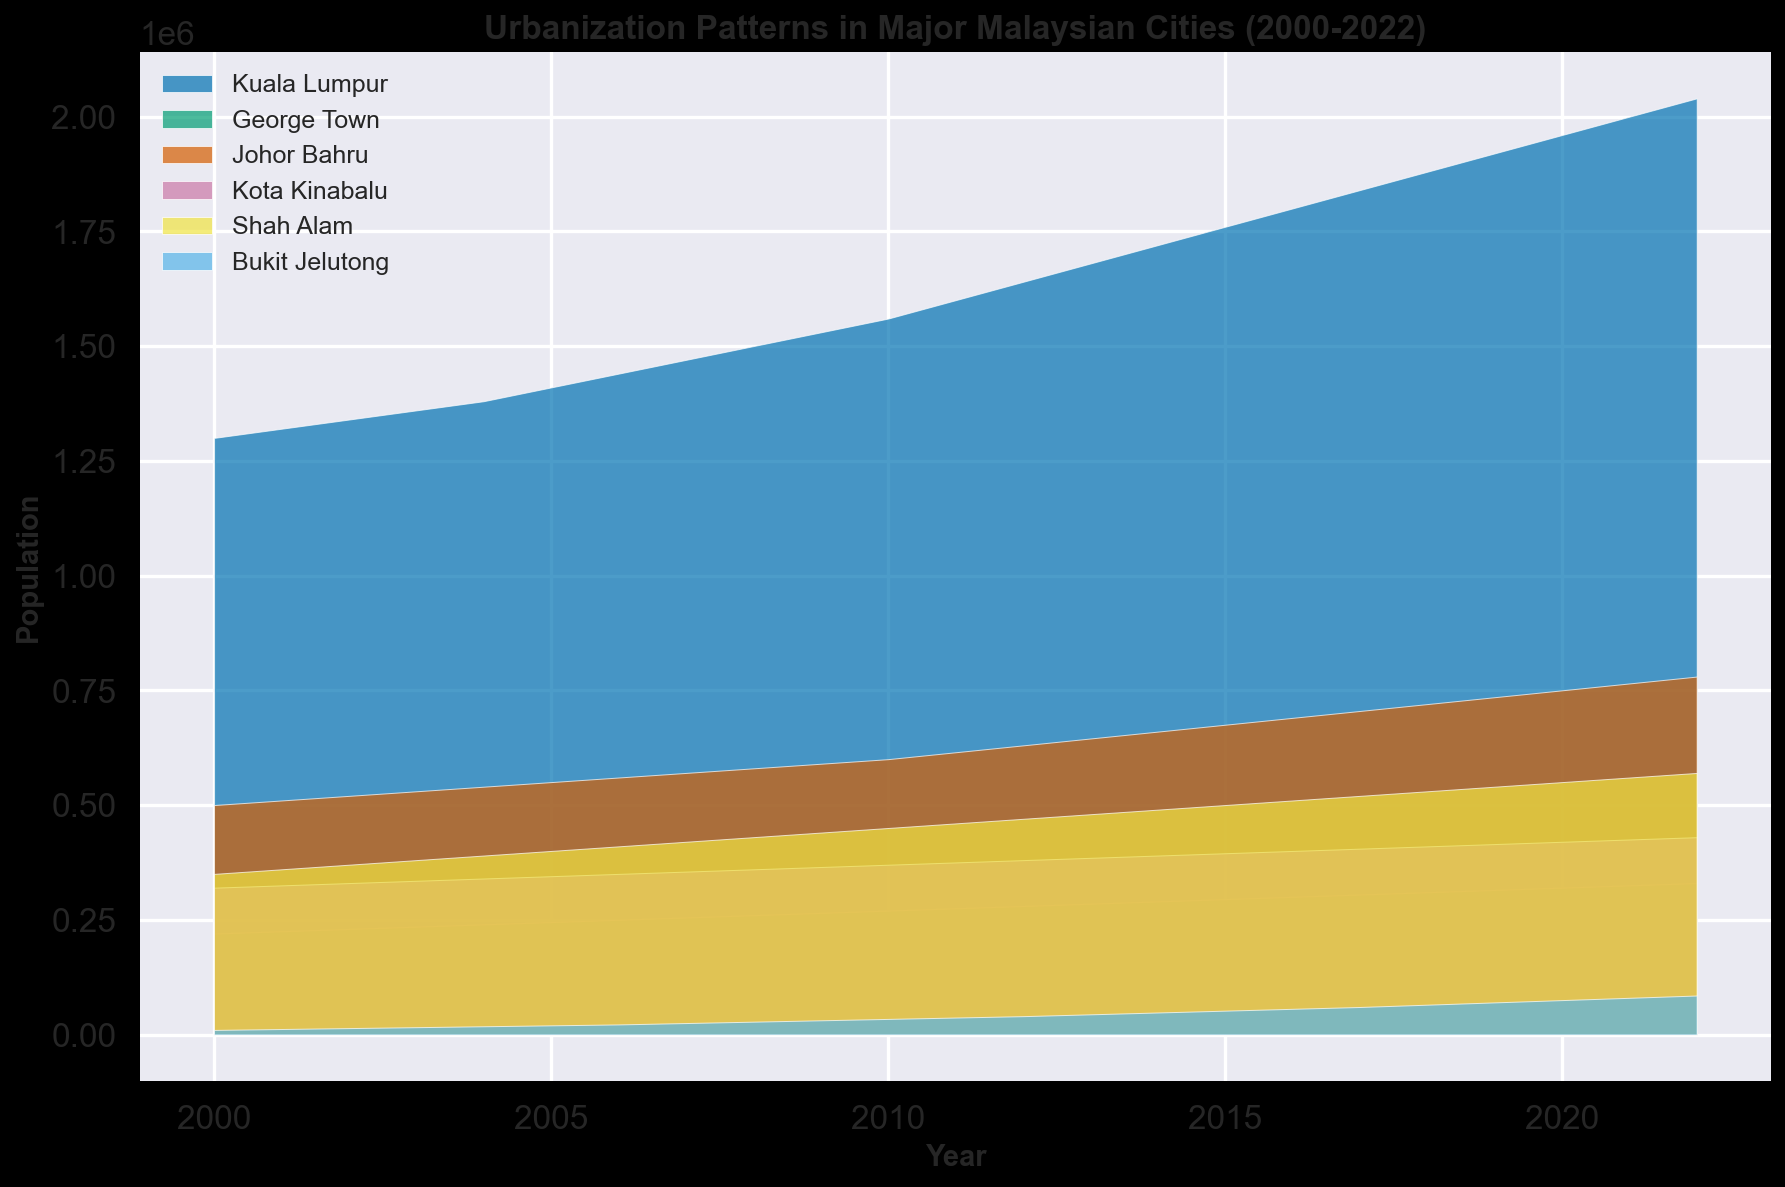Which city experienced the highest population growth from 2000 to 2022? To determine the city with the highest population growth, find the difference between the population values in 2022 and 2000 for each city. Compare these differences to identify the highest one. Kuala Lumpur grew from 1,300,000 to 2,040,000 (740,000 growth), George Town from 220,000 to 330,000 (110,000 growth), Johor Bahru from 500,000 to 780,000 (280,000 growth), Kota Kinabalu from 320,000 to 430,000 (110,000 growth), Shah Alam from 350,000 to 570,000 (220,000 growth), and Bukit Jelutong from 10,000 to 85,000 (75,000 growth). Thus, Kuala Lumpur had the highest growth.
Answer: Kuala Lumpur Compare the population trends of Shah Alam and Bukit Jelutong. Whose population increased more rapidly? To compare the trends, examine the slope or steepness of the area for Shah Alam and Bukit Jelutong. Shah Alam's population increased from 350,000 to 570,000 (220,000 growth) while Bukit Jelutong increased from 10,000 to 85,000 (75,000 growth). Despite Bukit Jelutong having a relatively smaller absolute increase, visually, its slope appears more rapid due to its smaller initial population.
Answer: Bukit Jelutong Which year did Bukit Jelutong’s population reach 50,000? To find the year when Bukit Jelutong’s population reached 50,000, look for the corresponding year in the plot. The population of Bukit Jelutong is 52,000 in 2015, so it reached 50,000 slightly before 2015.
Answer: 2015 In 2005, which city had the third-largest population? To determine the third-largest population in 2005, compare the populations of each city in that year. Kuala Lumpur had 1,410,000, George Town 245,000, Johor Bahru 550,000, Kota Kinabalu 345,000, Shah Alam 400,000, and Bukit Jelutong 20,000. Shah Alam, with 400,000, was the third-largest.
Answer: Shah Alam Is there any city whose population remained below 500,000 throughout the entire period? For this, observe populations for each city from 2000 to 2022. George Town, Kota Kinabalu, and Bukit Jelutong all had populations below 500,000 throughout this period, but Bukit Jelutong is notable for being substantially lower. George Town and Kota Kinabalu both had gradual increases, but still below 500,000.
Answer: Yes, Bukit Jelutong, George Town, Kota Kinabalu On visual inspection, how does the rate of population increase in Kuala Lumpur compare to Johor Bahru? Visually comparing the slopes of the areas for Kuala Lumpur and Johor Bahru, Kuala Lumpur has a steeper and more consistent upward slope compared to Johor Bahru, indicating a faster rate of population increase.
Answer: Kuala Lumpur By how much did the combined population of George Town and Kota Kinabalu increase from 2000 to 2022? To find the combined population increase, sum the respective increases. George Town increased from 220,000 to 330,000 (110,000) and Kota Kinabalu from 320,000 to 430,000 (110,000). The combined increase is 110,000 + 110,000 = 220,000.
Answer: 220,000 